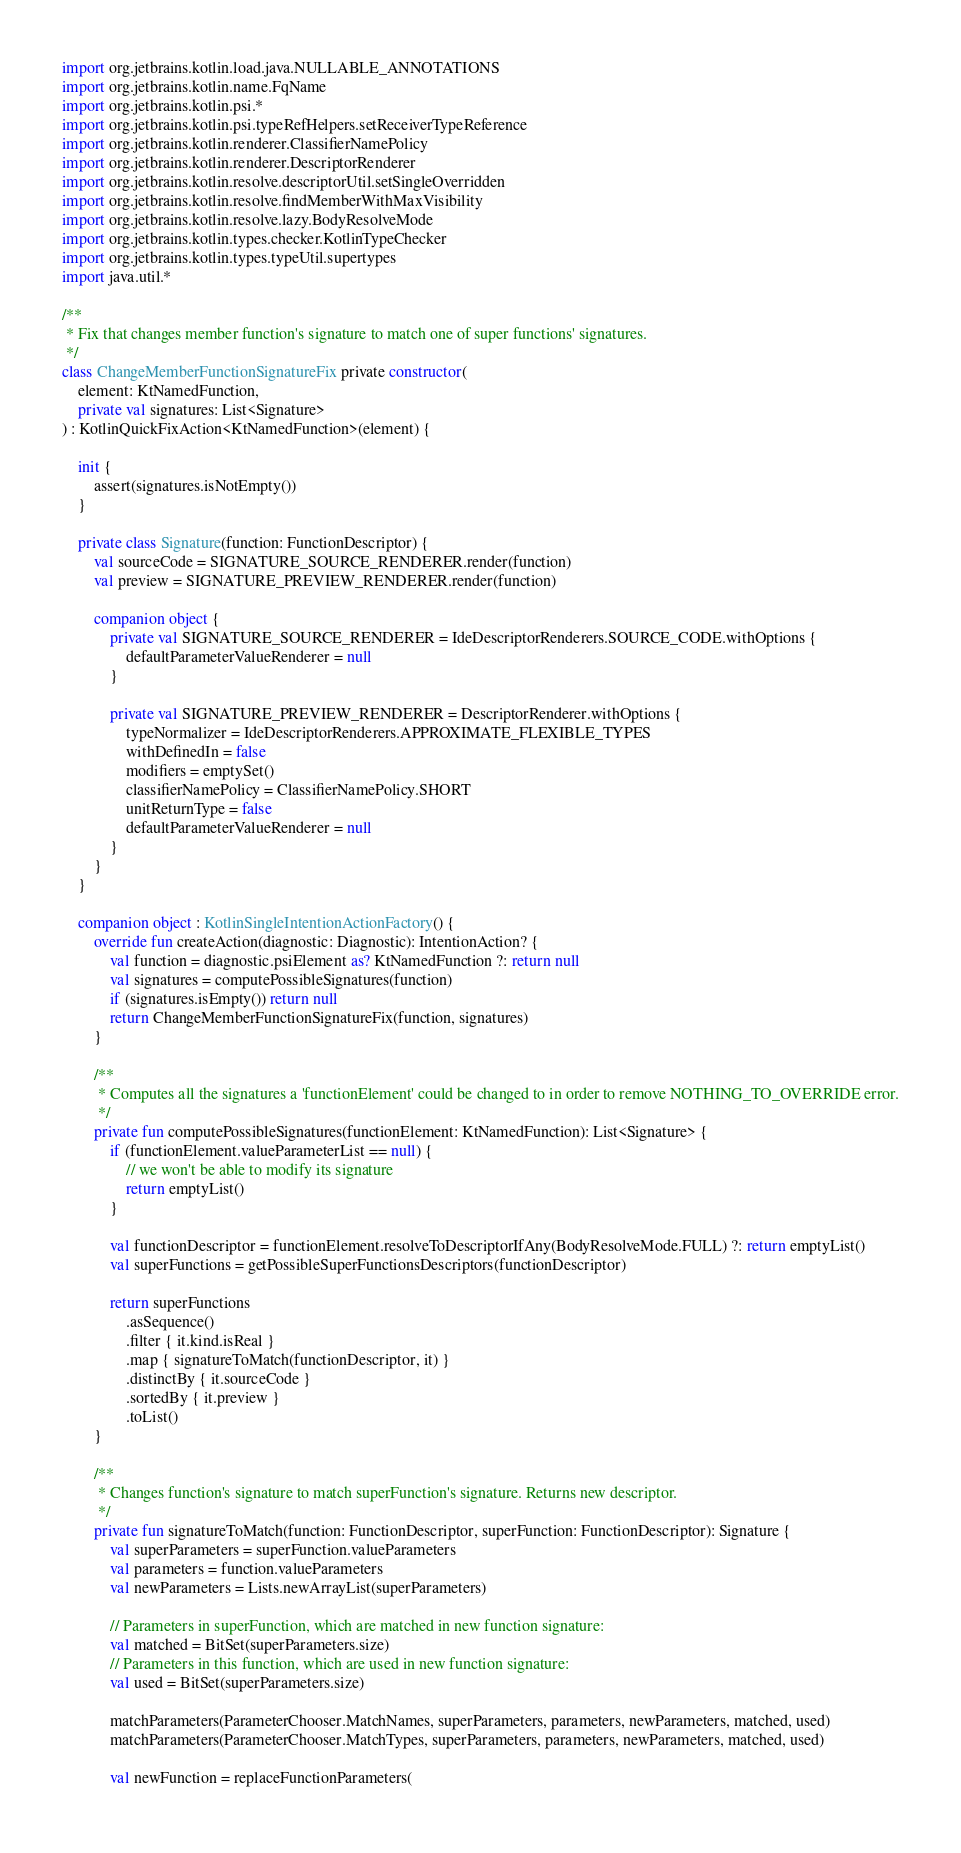<code> <loc_0><loc_0><loc_500><loc_500><_Kotlin_>import org.jetbrains.kotlin.load.java.NULLABLE_ANNOTATIONS
import org.jetbrains.kotlin.name.FqName
import org.jetbrains.kotlin.psi.*
import org.jetbrains.kotlin.psi.typeRefHelpers.setReceiverTypeReference
import org.jetbrains.kotlin.renderer.ClassifierNamePolicy
import org.jetbrains.kotlin.renderer.DescriptorRenderer
import org.jetbrains.kotlin.resolve.descriptorUtil.setSingleOverridden
import org.jetbrains.kotlin.resolve.findMemberWithMaxVisibility
import org.jetbrains.kotlin.resolve.lazy.BodyResolveMode
import org.jetbrains.kotlin.types.checker.KotlinTypeChecker
import org.jetbrains.kotlin.types.typeUtil.supertypes
import java.util.*

/**
 * Fix that changes member function's signature to match one of super functions' signatures.
 */
class ChangeMemberFunctionSignatureFix private constructor(
    element: KtNamedFunction,
    private val signatures: List<Signature>
) : KotlinQuickFixAction<KtNamedFunction>(element) {

    init {
        assert(signatures.isNotEmpty())
    }

    private class Signature(function: FunctionDescriptor) {
        val sourceCode = SIGNATURE_SOURCE_RENDERER.render(function)
        val preview = SIGNATURE_PREVIEW_RENDERER.render(function)

        companion object {
            private val SIGNATURE_SOURCE_RENDERER = IdeDescriptorRenderers.SOURCE_CODE.withOptions {
                defaultParameterValueRenderer = null
            }

            private val SIGNATURE_PREVIEW_RENDERER = DescriptorRenderer.withOptions {
                typeNormalizer = IdeDescriptorRenderers.APPROXIMATE_FLEXIBLE_TYPES
                withDefinedIn = false
                modifiers = emptySet()
                classifierNamePolicy = ClassifierNamePolicy.SHORT
                unitReturnType = false
                defaultParameterValueRenderer = null
            }
        }
    }

    companion object : KotlinSingleIntentionActionFactory() {
        override fun createAction(diagnostic: Diagnostic): IntentionAction? {
            val function = diagnostic.psiElement as? KtNamedFunction ?: return null
            val signatures = computePossibleSignatures(function)
            if (signatures.isEmpty()) return null
            return ChangeMemberFunctionSignatureFix(function, signatures)
        }

        /**
         * Computes all the signatures a 'functionElement' could be changed to in order to remove NOTHING_TO_OVERRIDE error.
         */
        private fun computePossibleSignatures(functionElement: KtNamedFunction): List<Signature> {
            if (functionElement.valueParameterList == null) {
                // we won't be able to modify its signature
                return emptyList()
            }

            val functionDescriptor = functionElement.resolveToDescriptorIfAny(BodyResolveMode.FULL) ?: return emptyList()
            val superFunctions = getPossibleSuperFunctionsDescriptors(functionDescriptor)

            return superFunctions
                .asSequence()
                .filter { it.kind.isReal }
                .map { signatureToMatch(functionDescriptor, it) }
                .distinctBy { it.sourceCode }
                .sortedBy { it.preview }
                .toList()
        }

        /**
         * Changes function's signature to match superFunction's signature. Returns new descriptor.
         */
        private fun signatureToMatch(function: FunctionDescriptor, superFunction: FunctionDescriptor): Signature {
            val superParameters = superFunction.valueParameters
            val parameters = function.valueParameters
            val newParameters = Lists.newArrayList(superParameters)

            // Parameters in superFunction, which are matched in new function signature:
            val matched = BitSet(superParameters.size)
            // Parameters in this function, which are used in new function signature:
            val used = BitSet(superParameters.size)

            matchParameters(ParameterChooser.MatchNames, superParameters, parameters, newParameters, matched, used)
            matchParameters(ParameterChooser.MatchTypes, superParameters, parameters, newParameters, matched, used)

            val newFunction = replaceFunctionParameters(</code> 